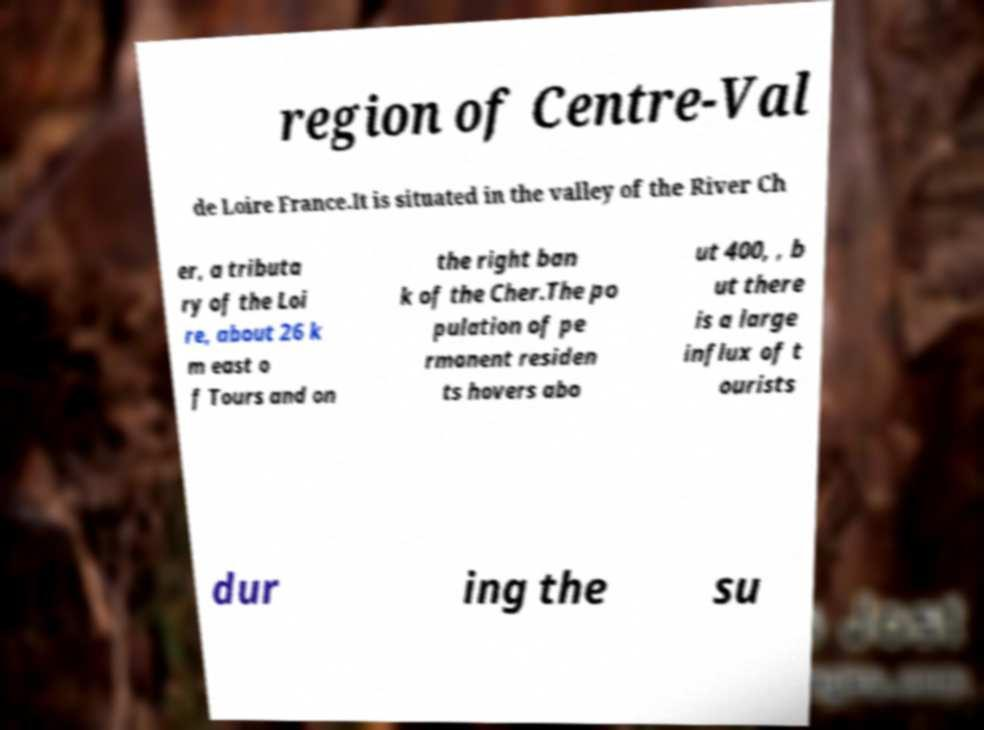There's text embedded in this image that I need extracted. Can you transcribe it verbatim? region of Centre-Val de Loire France.It is situated in the valley of the River Ch er, a tributa ry of the Loi re, about 26 k m east o f Tours and on the right ban k of the Cher.The po pulation of pe rmanent residen ts hovers abo ut 400, , b ut there is a large influx of t ourists dur ing the su 